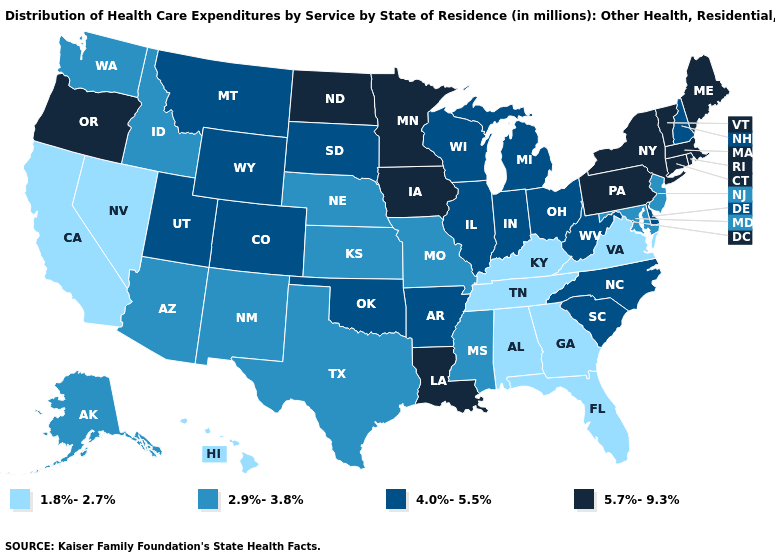Among the states that border Wisconsin , does Illinois have the highest value?
Keep it brief. No. Name the states that have a value in the range 4.0%-5.5%?
Be succinct. Arkansas, Colorado, Delaware, Illinois, Indiana, Michigan, Montana, New Hampshire, North Carolina, Ohio, Oklahoma, South Carolina, South Dakota, Utah, West Virginia, Wisconsin, Wyoming. Which states hav the highest value in the MidWest?
Concise answer only. Iowa, Minnesota, North Dakota. What is the highest value in the USA?
Write a very short answer. 5.7%-9.3%. What is the highest value in the USA?
Quick response, please. 5.7%-9.3%. What is the value of Illinois?
Be succinct. 4.0%-5.5%. What is the lowest value in the West?
Answer briefly. 1.8%-2.7%. Name the states that have a value in the range 1.8%-2.7%?
Concise answer only. Alabama, California, Florida, Georgia, Hawaii, Kentucky, Nevada, Tennessee, Virginia. What is the lowest value in the USA?
Short answer required. 1.8%-2.7%. What is the value of Nevada?
Give a very brief answer. 1.8%-2.7%. What is the value of West Virginia?
Quick response, please. 4.0%-5.5%. Name the states that have a value in the range 2.9%-3.8%?
Be succinct. Alaska, Arizona, Idaho, Kansas, Maryland, Mississippi, Missouri, Nebraska, New Jersey, New Mexico, Texas, Washington. What is the value of Rhode Island?
Short answer required. 5.7%-9.3%. What is the value of Utah?
Give a very brief answer. 4.0%-5.5%. What is the value of Louisiana?
Give a very brief answer. 5.7%-9.3%. 